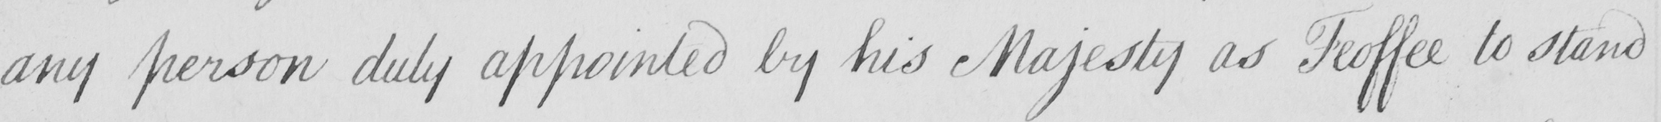Please provide the text content of this handwritten line. any person duly appointed by His Majesty as Feoffee to stand 